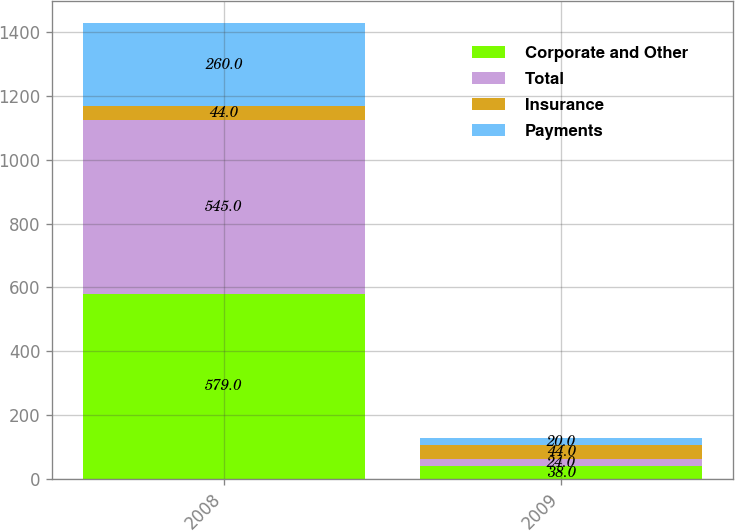<chart> <loc_0><loc_0><loc_500><loc_500><stacked_bar_chart><ecel><fcel>2008<fcel>2009<nl><fcel>Corporate and Other<fcel>579<fcel>38<nl><fcel>Total<fcel>545<fcel>24<nl><fcel>Insurance<fcel>44<fcel>44<nl><fcel>Payments<fcel>260<fcel>20<nl></chart> 